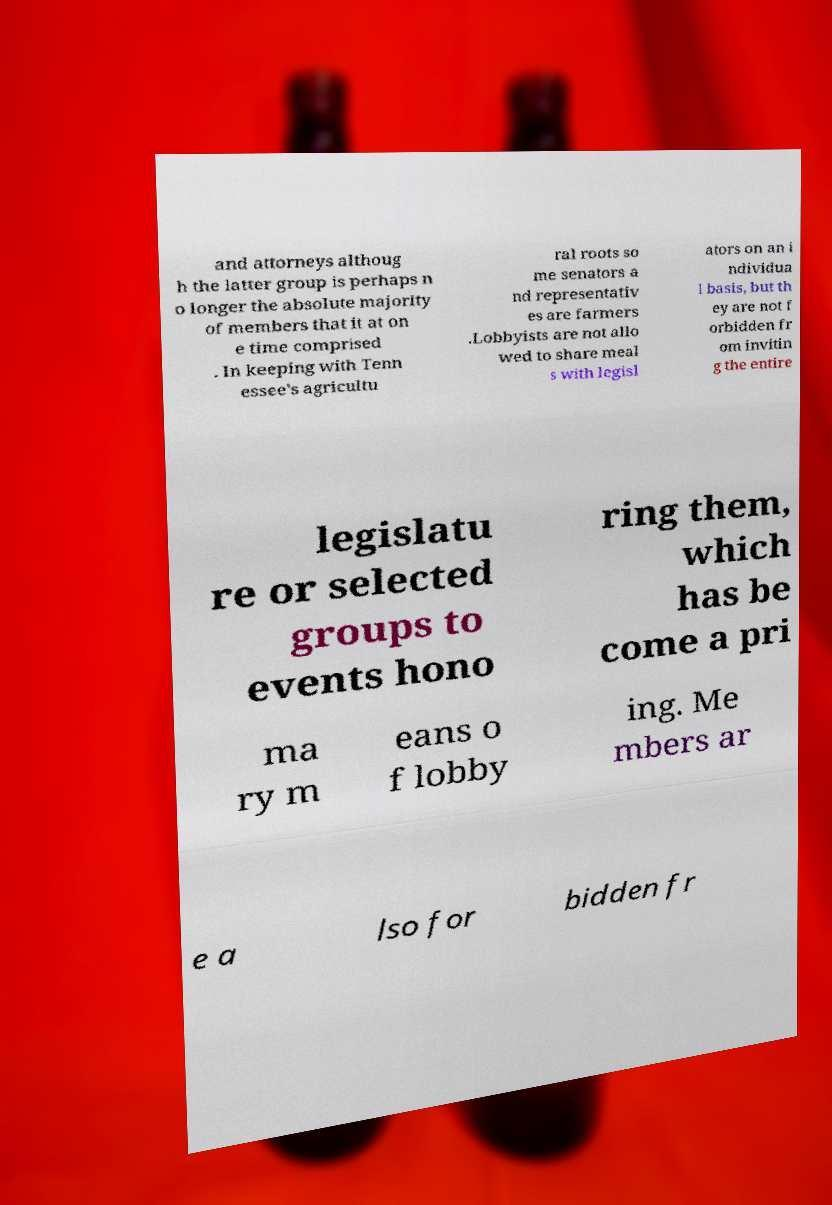Could you assist in decoding the text presented in this image and type it out clearly? and attorneys althoug h the latter group is perhaps n o longer the absolute majority of members that it at on e time comprised . In keeping with Tenn essee's agricultu ral roots so me senators a nd representativ es are farmers .Lobbyists are not allo wed to share meal s with legisl ators on an i ndividua l basis, but th ey are not f orbidden fr om invitin g the entire legislatu re or selected groups to events hono ring them, which has be come a pri ma ry m eans o f lobby ing. Me mbers ar e a lso for bidden fr 